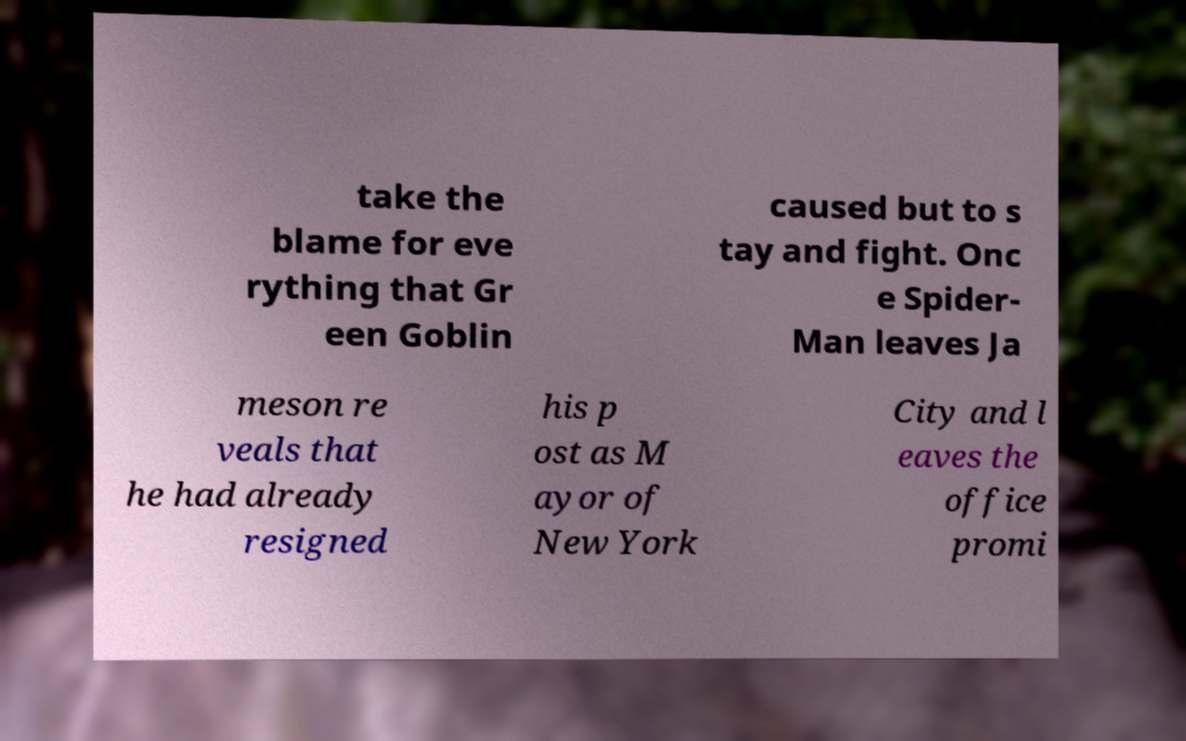Can you accurately transcribe the text from the provided image for me? take the blame for eve rything that Gr een Goblin caused but to s tay and fight. Onc e Spider- Man leaves Ja meson re veals that he had already resigned his p ost as M ayor of New York City and l eaves the office promi 